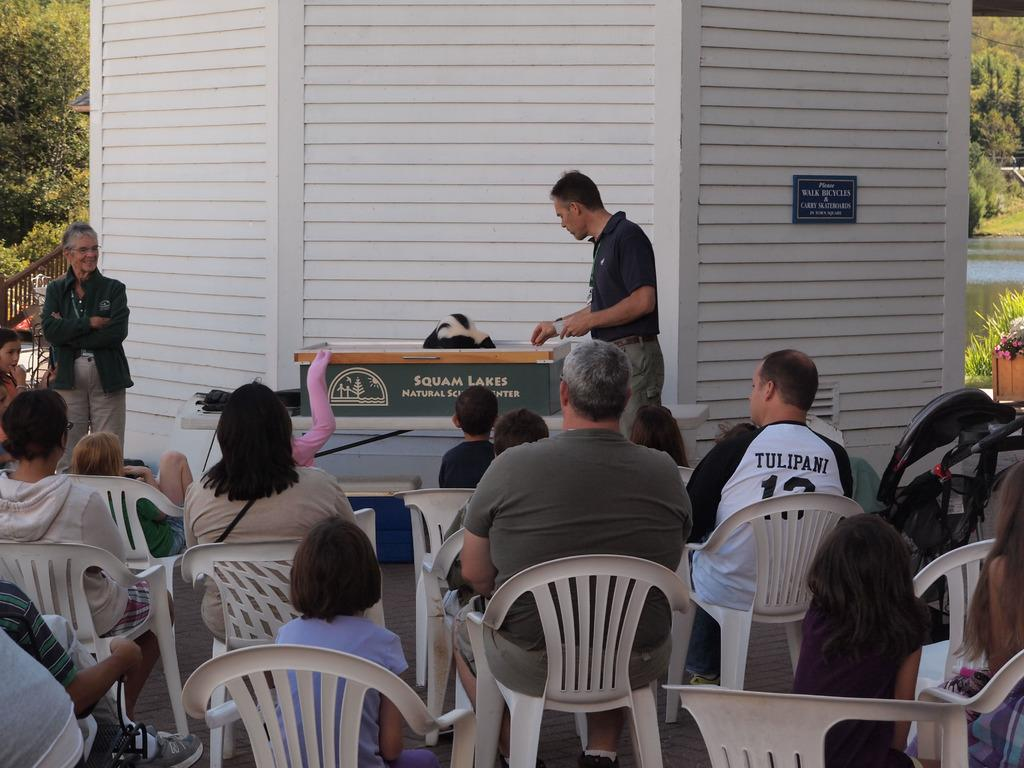Provide a one-sentence caption for the provided image. A Squam Lakes presentation with families in the audience. 